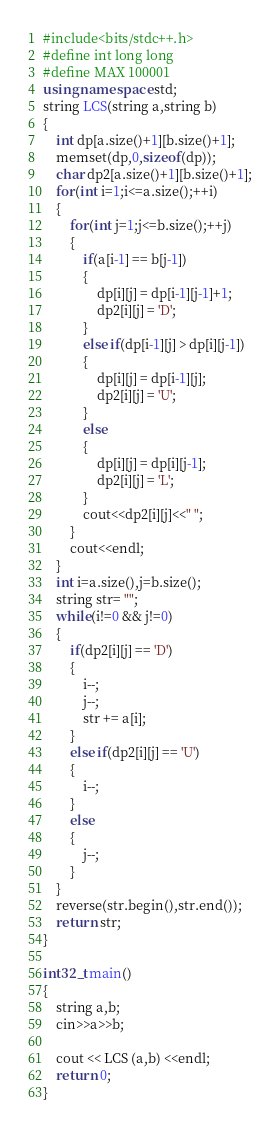<code> <loc_0><loc_0><loc_500><loc_500><_C++_>#include<bits/stdc++.h>
#define int long long
#define MAX 100001
using namespace std;
string LCS(string a,string b)
{
    int dp[a.size()+1][b.size()+1];
    memset(dp,0,sizeof(dp));
    char dp2[a.size()+1][b.size()+1];
    for(int i=1;i<=a.size();++i)
    {
        for(int j=1;j<=b.size();++j)
        {
            if(a[i-1] == b[j-1])
            {
                dp[i][j] = dp[i-1][j-1]+1;
                dp2[i][j] = 'D';
            }
            else if(dp[i-1][j] > dp[i][j-1])
            {
                dp[i][j] = dp[i-1][j];
                dp2[i][j] = 'U';
            }
            else
            {
                dp[i][j] = dp[i][j-1];
                dp2[i][j] = 'L';
            }
            cout<<dp2[i][j]<<" ";
        }
        cout<<endl;
    }
    int i=a.size(),j=b.size();
    string str= "";
    while(i!=0 && j!=0)
    {
        if(dp2[i][j] == 'D')
        {
            i--;
            j--;
            str += a[i];
        }
        else if(dp2[i][j] == 'U')
        {
            i--;
        }
        else
        {
            j--;
        }
    }
    reverse(str.begin(),str.end());
    return str;
}
 
int32_t main()
{
    string a,b;
    cin>>a>>b;
 
    cout << LCS (a,b) <<endl;
    return 0;
}</code> 